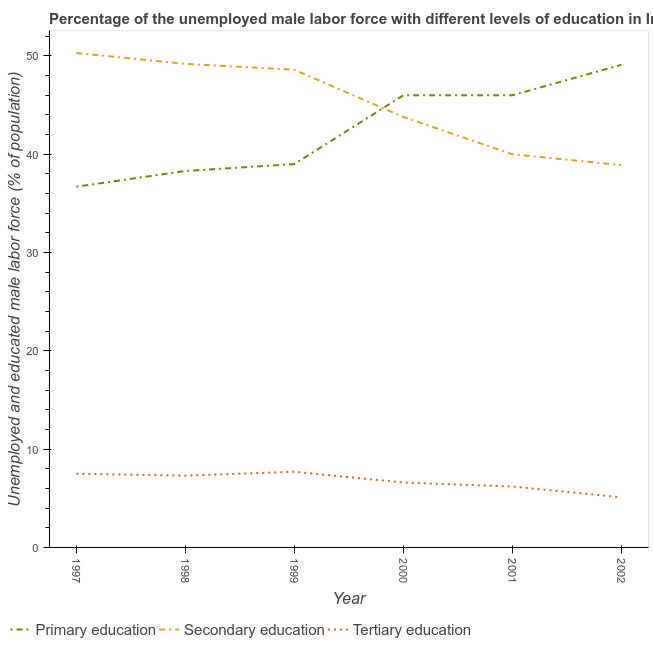Is the number of lines equal to the number of legend labels?
Offer a very short reply. Yes. What is the percentage of male labor force who received primary education in 1999?
Give a very brief answer. 39. Across all years, what is the maximum percentage of male labor force who received primary education?
Make the answer very short. 49.1. Across all years, what is the minimum percentage of male labor force who received tertiary education?
Your answer should be very brief. 5.1. In which year was the percentage of male labor force who received secondary education maximum?
Make the answer very short. 1997. What is the total percentage of male labor force who received secondary education in the graph?
Provide a short and direct response. 270.8. What is the difference between the percentage of male labor force who received tertiary education in 1998 and that in 2000?
Provide a succinct answer. 0.7. What is the difference between the percentage of male labor force who received secondary education in 1997 and the percentage of male labor force who received tertiary education in 2000?
Offer a terse response. 43.7. What is the average percentage of male labor force who received tertiary education per year?
Provide a short and direct response. 6.73. In the year 2001, what is the difference between the percentage of male labor force who received secondary education and percentage of male labor force who received tertiary education?
Give a very brief answer. 33.8. In how many years, is the percentage of male labor force who received primary education greater than 4 %?
Your response must be concise. 6. What is the ratio of the percentage of male labor force who received tertiary education in 1998 to that in 2001?
Provide a succinct answer. 1.18. Is the percentage of male labor force who received tertiary education in 1999 less than that in 2000?
Make the answer very short. No. What is the difference between the highest and the second highest percentage of male labor force who received secondary education?
Your answer should be compact. 1.1. What is the difference between the highest and the lowest percentage of male labor force who received tertiary education?
Give a very brief answer. 2.6. In how many years, is the percentage of male labor force who received secondary education greater than the average percentage of male labor force who received secondary education taken over all years?
Your answer should be compact. 3. Is the percentage of male labor force who received tertiary education strictly greater than the percentage of male labor force who received primary education over the years?
Ensure brevity in your answer.  No. Is the percentage of male labor force who received primary education strictly less than the percentage of male labor force who received secondary education over the years?
Make the answer very short. No. How many lines are there?
Offer a very short reply. 3. Are the values on the major ticks of Y-axis written in scientific E-notation?
Ensure brevity in your answer.  No. Where does the legend appear in the graph?
Your response must be concise. Bottom left. How many legend labels are there?
Give a very brief answer. 3. How are the legend labels stacked?
Your answer should be very brief. Horizontal. What is the title of the graph?
Your answer should be compact. Percentage of the unemployed male labor force with different levels of education in Indonesia. What is the label or title of the Y-axis?
Keep it short and to the point. Unemployed and educated male labor force (% of population). What is the Unemployed and educated male labor force (% of population) in Primary education in 1997?
Your answer should be compact. 36.7. What is the Unemployed and educated male labor force (% of population) in Secondary education in 1997?
Offer a terse response. 50.3. What is the Unemployed and educated male labor force (% of population) in Primary education in 1998?
Your answer should be very brief. 38.3. What is the Unemployed and educated male labor force (% of population) of Secondary education in 1998?
Offer a very short reply. 49.2. What is the Unemployed and educated male labor force (% of population) in Tertiary education in 1998?
Offer a very short reply. 7.3. What is the Unemployed and educated male labor force (% of population) in Primary education in 1999?
Keep it short and to the point. 39. What is the Unemployed and educated male labor force (% of population) in Secondary education in 1999?
Keep it short and to the point. 48.6. What is the Unemployed and educated male labor force (% of population) of Tertiary education in 1999?
Offer a terse response. 7.7. What is the Unemployed and educated male labor force (% of population) in Primary education in 2000?
Your answer should be compact. 46. What is the Unemployed and educated male labor force (% of population) in Secondary education in 2000?
Ensure brevity in your answer.  43.8. What is the Unemployed and educated male labor force (% of population) of Tertiary education in 2000?
Make the answer very short. 6.6. What is the Unemployed and educated male labor force (% of population) of Tertiary education in 2001?
Your response must be concise. 6.2. What is the Unemployed and educated male labor force (% of population) of Primary education in 2002?
Offer a terse response. 49.1. What is the Unemployed and educated male labor force (% of population) of Secondary education in 2002?
Provide a succinct answer. 38.9. What is the Unemployed and educated male labor force (% of population) in Tertiary education in 2002?
Provide a succinct answer. 5.1. Across all years, what is the maximum Unemployed and educated male labor force (% of population) in Primary education?
Ensure brevity in your answer.  49.1. Across all years, what is the maximum Unemployed and educated male labor force (% of population) of Secondary education?
Provide a short and direct response. 50.3. Across all years, what is the maximum Unemployed and educated male labor force (% of population) of Tertiary education?
Your response must be concise. 7.7. Across all years, what is the minimum Unemployed and educated male labor force (% of population) of Primary education?
Offer a terse response. 36.7. Across all years, what is the minimum Unemployed and educated male labor force (% of population) in Secondary education?
Offer a terse response. 38.9. Across all years, what is the minimum Unemployed and educated male labor force (% of population) in Tertiary education?
Keep it short and to the point. 5.1. What is the total Unemployed and educated male labor force (% of population) of Primary education in the graph?
Your answer should be very brief. 255.1. What is the total Unemployed and educated male labor force (% of population) of Secondary education in the graph?
Keep it short and to the point. 270.8. What is the total Unemployed and educated male labor force (% of population) in Tertiary education in the graph?
Make the answer very short. 40.4. What is the difference between the Unemployed and educated male labor force (% of population) in Primary education in 1997 and that in 1998?
Your answer should be very brief. -1.6. What is the difference between the Unemployed and educated male labor force (% of population) of Tertiary education in 1997 and that in 1998?
Your answer should be very brief. 0.2. What is the difference between the Unemployed and educated male labor force (% of population) in Secondary education in 1997 and that in 1999?
Provide a succinct answer. 1.7. What is the difference between the Unemployed and educated male labor force (% of population) in Tertiary education in 1997 and that in 2000?
Your answer should be very brief. 0.9. What is the difference between the Unemployed and educated male labor force (% of population) in Primary education in 1997 and that in 2002?
Ensure brevity in your answer.  -12.4. What is the difference between the Unemployed and educated male labor force (% of population) in Tertiary education in 1997 and that in 2002?
Keep it short and to the point. 2.4. What is the difference between the Unemployed and educated male labor force (% of population) in Secondary education in 1998 and that in 2000?
Make the answer very short. 5.4. What is the difference between the Unemployed and educated male labor force (% of population) of Tertiary education in 1998 and that in 2000?
Offer a very short reply. 0.7. What is the difference between the Unemployed and educated male labor force (% of population) of Secondary education in 1998 and that in 2001?
Provide a succinct answer. 9.2. What is the difference between the Unemployed and educated male labor force (% of population) of Primary education in 1998 and that in 2002?
Your answer should be very brief. -10.8. What is the difference between the Unemployed and educated male labor force (% of population) in Secondary education in 1998 and that in 2002?
Make the answer very short. 10.3. What is the difference between the Unemployed and educated male labor force (% of population) of Primary education in 1999 and that in 2000?
Offer a very short reply. -7. What is the difference between the Unemployed and educated male labor force (% of population) of Secondary education in 1999 and that in 2000?
Give a very brief answer. 4.8. What is the difference between the Unemployed and educated male labor force (% of population) of Primary education in 1999 and that in 2001?
Provide a short and direct response. -7. What is the difference between the Unemployed and educated male labor force (% of population) of Secondary education in 1999 and that in 2001?
Offer a very short reply. 8.6. What is the difference between the Unemployed and educated male labor force (% of population) in Primary education in 2000 and that in 2001?
Offer a very short reply. 0. What is the difference between the Unemployed and educated male labor force (% of population) of Tertiary education in 2000 and that in 2001?
Make the answer very short. 0.4. What is the difference between the Unemployed and educated male labor force (% of population) in Tertiary education in 2000 and that in 2002?
Provide a succinct answer. 1.5. What is the difference between the Unemployed and educated male labor force (% of population) in Primary education in 2001 and that in 2002?
Ensure brevity in your answer.  -3.1. What is the difference between the Unemployed and educated male labor force (% of population) in Primary education in 1997 and the Unemployed and educated male labor force (% of population) in Tertiary education in 1998?
Your answer should be compact. 29.4. What is the difference between the Unemployed and educated male labor force (% of population) of Primary education in 1997 and the Unemployed and educated male labor force (% of population) of Secondary education in 1999?
Make the answer very short. -11.9. What is the difference between the Unemployed and educated male labor force (% of population) of Secondary education in 1997 and the Unemployed and educated male labor force (% of population) of Tertiary education in 1999?
Provide a succinct answer. 42.6. What is the difference between the Unemployed and educated male labor force (% of population) in Primary education in 1997 and the Unemployed and educated male labor force (% of population) in Secondary education in 2000?
Give a very brief answer. -7.1. What is the difference between the Unemployed and educated male labor force (% of population) of Primary education in 1997 and the Unemployed and educated male labor force (% of population) of Tertiary education in 2000?
Make the answer very short. 30.1. What is the difference between the Unemployed and educated male labor force (% of population) of Secondary education in 1997 and the Unemployed and educated male labor force (% of population) of Tertiary education in 2000?
Offer a terse response. 43.7. What is the difference between the Unemployed and educated male labor force (% of population) in Primary education in 1997 and the Unemployed and educated male labor force (% of population) in Secondary education in 2001?
Your response must be concise. -3.3. What is the difference between the Unemployed and educated male labor force (% of population) in Primary education in 1997 and the Unemployed and educated male labor force (% of population) in Tertiary education in 2001?
Give a very brief answer. 30.5. What is the difference between the Unemployed and educated male labor force (% of population) of Secondary education in 1997 and the Unemployed and educated male labor force (% of population) of Tertiary education in 2001?
Offer a very short reply. 44.1. What is the difference between the Unemployed and educated male labor force (% of population) of Primary education in 1997 and the Unemployed and educated male labor force (% of population) of Tertiary education in 2002?
Provide a short and direct response. 31.6. What is the difference between the Unemployed and educated male labor force (% of population) in Secondary education in 1997 and the Unemployed and educated male labor force (% of population) in Tertiary education in 2002?
Your answer should be compact. 45.2. What is the difference between the Unemployed and educated male labor force (% of population) in Primary education in 1998 and the Unemployed and educated male labor force (% of population) in Tertiary education in 1999?
Ensure brevity in your answer.  30.6. What is the difference between the Unemployed and educated male labor force (% of population) in Secondary education in 1998 and the Unemployed and educated male labor force (% of population) in Tertiary education in 1999?
Provide a succinct answer. 41.5. What is the difference between the Unemployed and educated male labor force (% of population) in Primary education in 1998 and the Unemployed and educated male labor force (% of population) in Secondary education in 2000?
Offer a very short reply. -5.5. What is the difference between the Unemployed and educated male labor force (% of population) of Primary education in 1998 and the Unemployed and educated male labor force (% of population) of Tertiary education in 2000?
Offer a terse response. 31.7. What is the difference between the Unemployed and educated male labor force (% of population) in Secondary education in 1998 and the Unemployed and educated male labor force (% of population) in Tertiary education in 2000?
Provide a short and direct response. 42.6. What is the difference between the Unemployed and educated male labor force (% of population) of Primary education in 1998 and the Unemployed and educated male labor force (% of population) of Tertiary education in 2001?
Keep it short and to the point. 32.1. What is the difference between the Unemployed and educated male labor force (% of population) in Secondary education in 1998 and the Unemployed and educated male labor force (% of population) in Tertiary education in 2001?
Make the answer very short. 43. What is the difference between the Unemployed and educated male labor force (% of population) in Primary education in 1998 and the Unemployed and educated male labor force (% of population) in Secondary education in 2002?
Give a very brief answer. -0.6. What is the difference between the Unemployed and educated male labor force (% of population) in Primary education in 1998 and the Unemployed and educated male labor force (% of population) in Tertiary education in 2002?
Offer a terse response. 33.2. What is the difference between the Unemployed and educated male labor force (% of population) of Secondary education in 1998 and the Unemployed and educated male labor force (% of population) of Tertiary education in 2002?
Offer a very short reply. 44.1. What is the difference between the Unemployed and educated male labor force (% of population) in Primary education in 1999 and the Unemployed and educated male labor force (% of population) in Tertiary education in 2000?
Offer a very short reply. 32.4. What is the difference between the Unemployed and educated male labor force (% of population) in Primary education in 1999 and the Unemployed and educated male labor force (% of population) in Secondary education in 2001?
Your answer should be compact. -1. What is the difference between the Unemployed and educated male labor force (% of population) in Primary education in 1999 and the Unemployed and educated male labor force (% of population) in Tertiary education in 2001?
Your answer should be very brief. 32.8. What is the difference between the Unemployed and educated male labor force (% of population) in Secondary education in 1999 and the Unemployed and educated male labor force (% of population) in Tertiary education in 2001?
Provide a short and direct response. 42.4. What is the difference between the Unemployed and educated male labor force (% of population) of Primary education in 1999 and the Unemployed and educated male labor force (% of population) of Secondary education in 2002?
Your answer should be compact. 0.1. What is the difference between the Unemployed and educated male labor force (% of population) of Primary education in 1999 and the Unemployed and educated male labor force (% of population) of Tertiary education in 2002?
Ensure brevity in your answer.  33.9. What is the difference between the Unemployed and educated male labor force (% of population) in Secondary education in 1999 and the Unemployed and educated male labor force (% of population) in Tertiary education in 2002?
Your answer should be very brief. 43.5. What is the difference between the Unemployed and educated male labor force (% of population) of Primary education in 2000 and the Unemployed and educated male labor force (% of population) of Secondary education in 2001?
Ensure brevity in your answer.  6. What is the difference between the Unemployed and educated male labor force (% of population) in Primary education in 2000 and the Unemployed and educated male labor force (% of population) in Tertiary education in 2001?
Provide a short and direct response. 39.8. What is the difference between the Unemployed and educated male labor force (% of population) of Secondary education in 2000 and the Unemployed and educated male labor force (% of population) of Tertiary education in 2001?
Give a very brief answer. 37.6. What is the difference between the Unemployed and educated male labor force (% of population) of Primary education in 2000 and the Unemployed and educated male labor force (% of population) of Secondary education in 2002?
Make the answer very short. 7.1. What is the difference between the Unemployed and educated male labor force (% of population) in Primary education in 2000 and the Unemployed and educated male labor force (% of population) in Tertiary education in 2002?
Your response must be concise. 40.9. What is the difference between the Unemployed and educated male labor force (% of population) in Secondary education in 2000 and the Unemployed and educated male labor force (% of population) in Tertiary education in 2002?
Ensure brevity in your answer.  38.7. What is the difference between the Unemployed and educated male labor force (% of population) of Primary education in 2001 and the Unemployed and educated male labor force (% of population) of Secondary education in 2002?
Provide a succinct answer. 7.1. What is the difference between the Unemployed and educated male labor force (% of population) in Primary education in 2001 and the Unemployed and educated male labor force (% of population) in Tertiary education in 2002?
Keep it short and to the point. 40.9. What is the difference between the Unemployed and educated male labor force (% of population) of Secondary education in 2001 and the Unemployed and educated male labor force (% of population) of Tertiary education in 2002?
Offer a very short reply. 34.9. What is the average Unemployed and educated male labor force (% of population) of Primary education per year?
Provide a short and direct response. 42.52. What is the average Unemployed and educated male labor force (% of population) in Secondary education per year?
Your response must be concise. 45.13. What is the average Unemployed and educated male labor force (% of population) in Tertiary education per year?
Provide a succinct answer. 6.73. In the year 1997, what is the difference between the Unemployed and educated male labor force (% of population) of Primary education and Unemployed and educated male labor force (% of population) of Secondary education?
Offer a very short reply. -13.6. In the year 1997, what is the difference between the Unemployed and educated male labor force (% of population) of Primary education and Unemployed and educated male labor force (% of population) of Tertiary education?
Give a very brief answer. 29.2. In the year 1997, what is the difference between the Unemployed and educated male labor force (% of population) of Secondary education and Unemployed and educated male labor force (% of population) of Tertiary education?
Offer a terse response. 42.8. In the year 1998, what is the difference between the Unemployed and educated male labor force (% of population) of Primary education and Unemployed and educated male labor force (% of population) of Secondary education?
Make the answer very short. -10.9. In the year 1998, what is the difference between the Unemployed and educated male labor force (% of population) of Secondary education and Unemployed and educated male labor force (% of population) of Tertiary education?
Offer a very short reply. 41.9. In the year 1999, what is the difference between the Unemployed and educated male labor force (% of population) in Primary education and Unemployed and educated male labor force (% of population) in Tertiary education?
Provide a succinct answer. 31.3. In the year 1999, what is the difference between the Unemployed and educated male labor force (% of population) in Secondary education and Unemployed and educated male labor force (% of population) in Tertiary education?
Keep it short and to the point. 40.9. In the year 2000, what is the difference between the Unemployed and educated male labor force (% of population) of Primary education and Unemployed and educated male labor force (% of population) of Tertiary education?
Ensure brevity in your answer.  39.4. In the year 2000, what is the difference between the Unemployed and educated male labor force (% of population) in Secondary education and Unemployed and educated male labor force (% of population) in Tertiary education?
Keep it short and to the point. 37.2. In the year 2001, what is the difference between the Unemployed and educated male labor force (% of population) in Primary education and Unemployed and educated male labor force (% of population) in Secondary education?
Ensure brevity in your answer.  6. In the year 2001, what is the difference between the Unemployed and educated male labor force (% of population) in Primary education and Unemployed and educated male labor force (% of population) in Tertiary education?
Give a very brief answer. 39.8. In the year 2001, what is the difference between the Unemployed and educated male labor force (% of population) of Secondary education and Unemployed and educated male labor force (% of population) of Tertiary education?
Your answer should be very brief. 33.8. In the year 2002, what is the difference between the Unemployed and educated male labor force (% of population) in Primary education and Unemployed and educated male labor force (% of population) in Secondary education?
Give a very brief answer. 10.2. In the year 2002, what is the difference between the Unemployed and educated male labor force (% of population) in Secondary education and Unemployed and educated male labor force (% of population) in Tertiary education?
Your response must be concise. 33.8. What is the ratio of the Unemployed and educated male labor force (% of population) of Primary education in 1997 to that in 1998?
Provide a short and direct response. 0.96. What is the ratio of the Unemployed and educated male labor force (% of population) in Secondary education in 1997 to that in 1998?
Ensure brevity in your answer.  1.02. What is the ratio of the Unemployed and educated male labor force (% of population) in Tertiary education in 1997 to that in 1998?
Provide a succinct answer. 1.03. What is the ratio of the Unemployed and educated male labor force (% of population) of Primary education in 1997 to that in 1999?
Provide a short and direct response. 0.94. What is the ratio of the Unemployed and educated male labor force (% of population) in Secondary education in 1997 to that in 1999?
Give a very brief answer. 1.03. What is the ratio of the Unemployed and educated male labor force (% of population) in Tertiary education in 1997 to that in 1999?
Your answer should be very brief. 0.97. What is the ratio of the Unemployed and educated male labor force (% of population) of Primary education in 1997 to that in 2000?
Give a very brief answer. 0.8. What is the ratio of the Unemployed and educated male labor force (% of population) of Secondary education in 1997 to that in 2000?
Offer a very short reply. 1.15. What is the ratio of the Unemployed and educated male labor force (% of population) in Tertiary education in 1997 to that in 2000?
Provide a short and direct response. 1.14. What is the ratio of the Unemployed and educated male labor force (% of population) in Primary education in 1997 to that in 2001?
Provide a succinct answer. 0.8. What is the ratio of the Unemployed and educated male labor force (% of population) in Secondary education in 1997 to that in 2001?
Give a very brief answer. 1.26. What is the ratio of the Unemployed and educated male labor force (% of population) in Tertiary education in 1997 to that in 2001?
Provide a succinct answer. 1.21. What is the ratio of the Unemployed and educated male labor force (% of population) of Primary education in 1997 to that in 2002?
Make the answer very short. 0.75. What is the ratio of the Unemployed and educated male labor force (% of population) in Secondary education in 1997 to that in 2002?
Your answer should be compact. 1.29. What is the ratio of the Unemployed and educated male labor force (% of population) in Tertiary education in 1997 to that in 2002?
Your answer should be compact. 1.47. What is the ratio of the Unemployed and educated male labor force (% of population) in Primary education in 1998 to that in 1999?
Your answer should be compact. 0.98. What is the ratio of the Unemployed and educated male labor force (% of population) in Secondary education in 1998 to that in 1999?
Provide a succinct answer. 1.01. What is the ratio of the Unemployed and educated male labor force (% of population) in Tertiary education in 1998 to that in 1999?
Give a very brief answer. 0.95. What is the ratio of the Unemployed and educated male labor force (% of population) in Primary education in 1998 to that in 2000?
Offer a very short reply. 0.83. What is the ratio of the Unemployed and educated male labor force (% of population) of Secondary education in 1998 to that in 2000?
Provide a succinct answer. 1.12. What is the ratio of the Unemployed and educated male labor force (% of population) of Tertiary education in 1998 to that in 2000?
Your response must be concise. 1.11. What is the ratio of the Unemployed and educated male labor force (% of population) of Primary education in 1998 to that in 2001?
Your response must be concise. 0.83. What is the ratio of the Unemployed and educated male labor force (% of population) in Secondary education in 1998 to that in 2001?
Your answer should be very brief. 1.23. What is the ratio of the Unemployed and educated male labor force (% of population) of Tertiary education in 1998 to that in 2001?
Provide a succinct answer. 1.18. What is the ratio of the Unemployed and educated male labor force (% of population) in Primary education in 1998 to that in 2002?
Provide a short and direct response. 0.78. What is the ratio of the Unemployed and educated male labor force (% of population) of Secondary education in 1998 to that in 2002?
Ensure brevity in your answer.  1.26. What is the ratio of the Unemployed and educated male labor force (% of population) of Tertiary education in 1998 to that in 2002?
Provide a short and direct response. 1.43. What is the ratio of the Unemployed and educated male labor force (% of population) in Primary education in 1999 to that in 2000?
Keep it short and to the point. 0.85. What is the ratio of the Unemployed and educated male labor force (% of population) in Secondary education in 1999 to that in 2000?
Make the answer very short. 1.11. What is the ratio of the Unemployed and educated male labor force (% of population) of Tertiary education in 1999 to that in 2000?
Your answer should be compact. 1.17. What is the ratio of the Unemployed and educated male labor force (% of population) in Primary education in 1999 to that in 2001?
Provide a succinct answer. 0.85. What is the ratio of the Unemployed and educated male labor force (% of population) of Secondary education in 1999 to that in 2001?
Provide a short and direct response. 1.22. What is the ratio of the Unemployed and educated male labor force (% of population) of Tertiary education in 1999 to that in 2001?
Provide a short and direct response. 1.24. What is the ratio of the Unemployed and educated male labor force (% of population) of Primary education in 1999 to that in 2002?
Give a very brief answer. 0.79. What is the ratio of the Unemployed and educated male labor force (% of population) of Secondary education in 1999 to that in 2002?
Offer a very short reply. 1.25. What is the ratio of the Unemployed and educated male labor force (% of population) of Tertiary education in 1999 to that in 2002?
Provide a succinct answer. 1.51. What is the ratio of the Unemployed and educated male labor force (% of population) of Secondary education in 2000 to that in 2001?
Give a very brief answer. 1.09. What is the ratio of the Unemployed and educated male labor force (% of population) in Tertiary education in 2000 to that in 2001?
Your answer should be compact. 1.06. What is the ratio of the Unemployed and educated male labor force (% of population) of Primary education in 2000 to that in 2002?
Your answer should be compact. 0.94. What is the ratio of the Unemployed and educated male labor force (% of population) in Secondary education in 2000 to that in 2002?
Keep it short and to the point. 1.13. What is the ratio of the Unemployed and educated male labor force (% of population) in Tertiary education in 2000 to that in 2002?
Ensure brevity in your answer.  1.29. What is the ratio of the Unemployed and educated male labor force (% of population) in Primary education in 2001 to that in 2002?
Your response must be concise. 0.94. What is the ratio of the Unemployed and educated male labor force (% of population) in Secondary education in 2001 to that in 2002?
Keep it short and to the point. 1.03. What is the ratio of the Unemployed and educated male labor force (% of population) in Tertiary education in 2001 to that in 2002?
Give a very brief answer. 1.22. What is the difference between the highest and the second highest Unemployed and educated male labor force (% of population) of Primary education?
Keep it short and to the point. 3.1. What is the difference between the highest and the second highest Unemployed and educated male labor force (% of population) of Secondary education?
Ensure brevity in your answer.  1.1. What is the difference between the highest and the lowest Unemployed and educated male labor force (% of population) of Primary education?
Offer a very short reply. 12.4. What is the difference between the highest and the lowest Unemployed and educated male labor force (% of population) of Secondary education?
Your response must be concise. 11.4. 